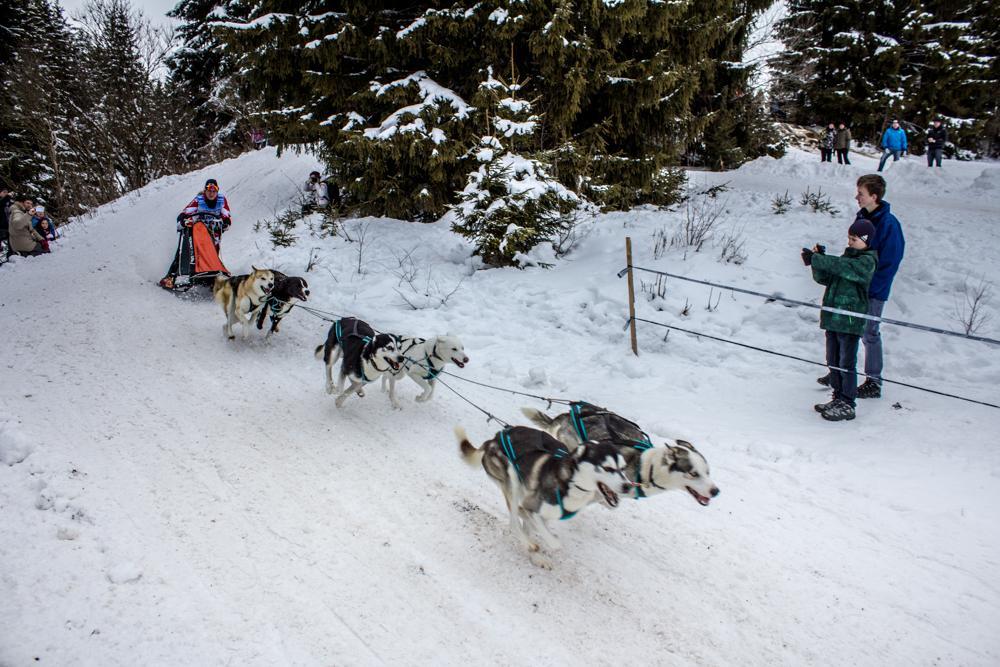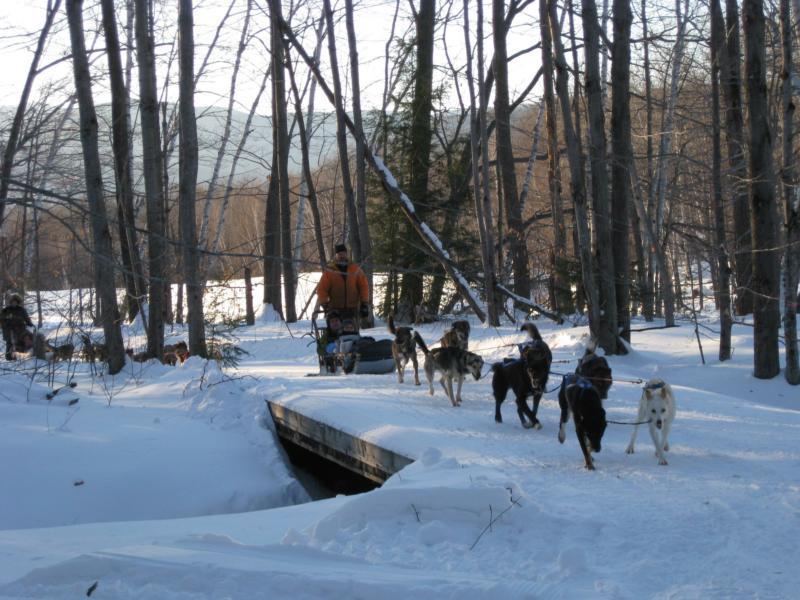The first image is the image on the left, the second image is the image on the right. Evaluate the accuracy of this statement regarding the images: "All the sled dogs in the left image are running towards the left.". Is it true? Answer yes or no. No. The first image is the image on the left, the second image is the image on the right. For the images shown, is this caption "A sled driver in red and black leads a team of dogs diagonally to the left past stands of evergreen trees." true? Answer yes or no. No. 